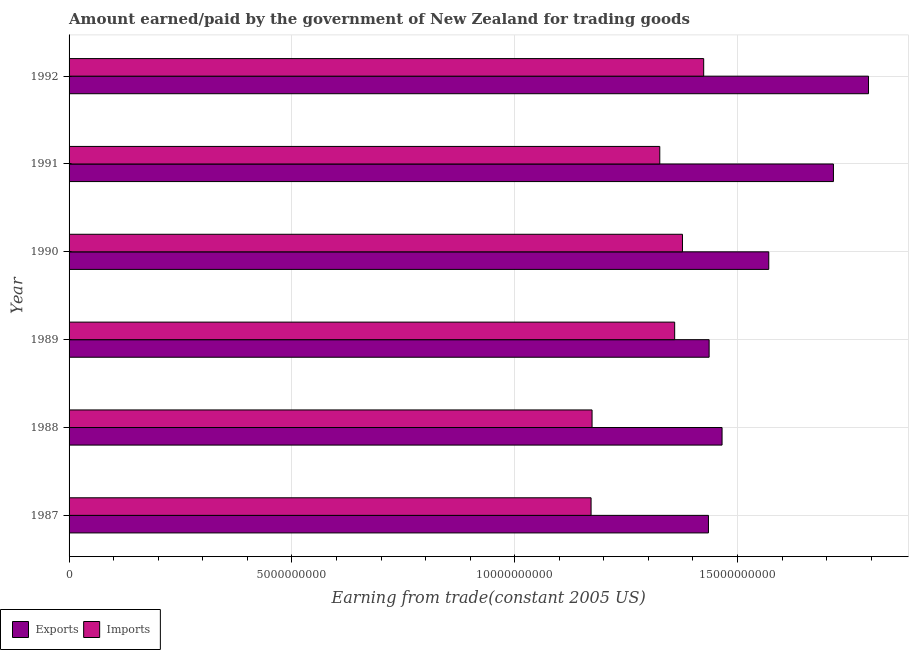How many groups of bars are there?
Provide a short and direct response. 6. Are the number of bars per tick equal to the number of legend labels?
Offer a very short reply. Yes. How many bars are there on the 3rd tick from the top?
Offer a very short reply. 2. How many bars are there on the 6th tick from the bottom?
Keep it short and to the point. 2. What is the amount earned from exports in 1992?
Offer a very short reply. 1.79e+1. Across all years, what is the maximum amount earned from exports?
Offer a very short reply. 1.79e+1. Across all years, what is the minimum amount earned from exports?
Provide a short and direct response. 1.43e+1. What is the total amount earned from exports in the graph?
Ensure brevity in your answer.  9.42e+1. What is the difference between the amount paid for imports in 1988 and that in 1990?
Ensure brevity in your answer.  -2.03e+09. What is the difference between the amount paid for imports in 1990 and the amount earned from exports in 1989?
Your answer should be compact. -5.98e+08. What is the average amount earned from exports per year?
Your answer should be compact. 1.57e+1. In the year 1992, what is the difference between the amount paid for imports and amount earned from exports?
Your answer should be compact. -3.70e+09. What is the ratio of the amount paid for imports in 1987 to that in 1992?
Ensure brevity in your answer.  0.82. Is the amount paid for imports in 1989 less than that in 1990?
Provide a succinct answer. Yes. Is the difference between the amount earned from exports in 1987 and 1992 greater than the difference between the amount paid for imports in 1987 and 1992?
Make the answer very short. No. What is the difference between the highest and the second highest amount earned from exports?
Offer a very short reply. 7.87e+08. What is the difference between the highest and the lowest amount paid for imports?
Offer a very short reply. 2.53e+09. What does the 1st bar from the top in 1989 represents?
Your answer should be very brief. Imports. What does the 1st bar from the bottom in 1987 represents?
Provide a succinct answer. Exports. Are all the bars in the graph horizontal?
Keep it short and to the point. Yes. How many years are there in the graph?
Provide a short and direct response. 6. What is the difference between two consecutive major ticks on the X-axis?
Give a very brief answer. 5.00e+09. Are the values on the major ticks of X-axis written in scientific E-notation?
Ensure brevity in your answer.  No. How are the legend labels stacked?
Keep it short and to the point. Horizontal. What is the title of the graph?
Make the answer very short. Amount earned/paid by the government of New Zealand for trading goods. Does "By country of origin" appear as one of the legend labels in the graph?
Ensure brevity in your answer.  No. What is the label or title of the X-axis?
Your answer should be compact. Earning from trade(constant 2005 US). What is the Earning from trade(constant 2005 US) in Exports in 1987?
Offer a terse response. 1.43e+1. What is the Earning from trade(constant 2005 US) in Imports in 1987?
Offer a terse response. 1.17e+1. What is the Earning from trade(constant 2005 US) of Exports in 1988?
Ensure brevity in your answer.  1.47e+1. What is the Earning from trade(constant 2005 US) in Imports in 1988?
Your answer should be very brief. 1.17e+1. What is the Earning from trade(constant 2005 US) of Exports in 1989?
Provide a short and direct response. 1.44e+1. What is the Earning from trade(constant 2005 US) in Imports in 1989?
Provide a succinct answer. 1.36e+1. What is the Earning from trade(constant 2005 US) in Exports in 1990?
Ensure brevity in your answer.  1.57e+1. What is the Earning from trade(constant 2005 US) in Imports in 1990?
Provide a short and direct response. 1.38e+1. What is the Earning from trade(constant 2005 US) in Exports in 1991?
Your response must be concise. 1.72e+1. What is the Earning from trade(constant 2005 US) in Imports in 1991?
Offer a very short reply. 1.33e+1. What is the Earning from trade(constant 2005 US) in Exports in 1992?
Your answer should be compact. 1.79e+1. What is the Earning from trade(constant 2005 US) of Imports in 1992?
Give a very brief answer. 1.42e+1. Across all years, what is the maximum Earning from trade(constant 2005 US) of Exports?
Your answer should be compact. 1.79e+1. Across all years, what is the maximum Earning from trade(constant 2005 US) of Imports?
Provide a succinct answer. 1.42e+1. Across all years, what is the minimum Earning from trade(constant 2005 US) in Exports?
Offer a terse response. 1.43e+1. Across all years, what is the minimum Earning from trade(constant 2005 US) of Imports?
Provide a short and direct response. 1.17e+1. What is the total Earning from trade(constant 2005 US) in Exports in the graph?
Provide a short and direct response. 9.42e+1. What is the total Earning from trade(constant 2005 US) in Imports in the graph?
Ensure brevity in your answer.  7.83e+1. What is the difference between the Earning from trade(constant 2005 US) of Exports in 1987 and that in 1988?
Offer a very short reply. -3.05e+08. What is the difference between the Earning from trade(constant 2005 US) in Imports in 1987 and that in 1988?
Your answer should be very brief. -2.22e+07. What is the difference between the Earning from trade(constant 2005 US) of Exports in 1987 and that in 1989?
Make the answer very short. -1.52e+07. What is the difference between the Earning from trade(constant 2005 US) in Imports in 1987 and that in 1989?
Your answer should be very brief. -1.88e+09. What is the difference between the Earning from trade(constant 2005 US) of Exports in 1987 and that in 1990?
Your response must be concise. -1.35e+09. What is the difference between the Earning from trade(constant 2005 US) of Imports in 1987 and that in 1990?
Provide a succinct answer. -2.05e+09. What is the difference between the Earning from trade(constant 2005 US) of Exports in 1987 and that in 1991?
Your answer should be very brief. -2.80e+09. What is the difference between the Earning from trade(constant 2005 US) in Imports in 1987 and that in 1991?
Your answer should be compact. -1.54e+09. What is the difference between the Earning from trade(constant 2005 US) in Exports in 1987 and that in 1992?
Your answer should be compact. -3.59e+09. What is the difference between the Earning from trade(constant 2005 US) in Imports in 1987 and that in 1992?
Provide a succinct answer. -2.53e+09. What is the difference between the Earning from trade(constant 2005 US) of Exports in 1988 and that in 1989?
Your answer should be compact. 2.90e+08. What is the difference between the Earning from trade(constant 2005 US) in Imports in 1988 and that in 1989?
Provide a short and direct response. -1.85e+09. What is the difference between the Earning from trade(constant 2005 US) in Exports in 1988 and that in 1990?
Your answer should be compact. -1.05e+09. What is the difference between the Earning from trade(constant 2005 US) of Imports in 1988 and that in 1990?
Give a very brief answer. -2.03e+09. What is the difference between the Earning from trade(constant 2005 US) of Exports in 1988 and that in 1991?
Make the answer very short. -2.50e+09. What is the difference between the Earning from trade(constant 2005 US) of Imports in 1988 and that in 1991?
Keep it short and to the point. -1.52e+09. What is the difference between the Earning from trade(constant 2005 US) in Exports in 1988 and that in 1992?
Provide a succinct answer. -3.29e+09. What is the difference between the Earning from trade(constant 2005 US) of Imports in 1988 and that in 1992?
Offer a terse response. -2.51e+09. What is the difference between the Earning from trade(constant 2005 US) of Exports in 1989 and that in 1990?
Offer a very short reply. -1.34e+09. What is the difference between the Earning from trade(constant 2005 US) in Imports in 1989 and that in 1990?
Keep it short and to the point. -1.75e+08. What is the difference between the Earning from trade(constant 2005 US) of Exports in 1989 and that in 1991?
Keep it short and to the point. -2.79e+09. What is the difference between the Earning from trade(constant 2005 US) in Imports in 1989 and that in 1991?
Keep it short and to the point. 3.34e+08. What is the difference between the Earning from trade(constant 2005 US) in Exports in 1989 and that in 1992?
Provide a short and direct response. -3.58e+09. What is the difference between the Earning from trade(constant 2005 US) of Imports in 1989 and that in 1992?
Your answer should be compact. -6.51e+08. What is the difference between the Earning from trade(constant 2005 US) of Exports in 1990 and that in 1991?
Provide a succinct answer. -1.45e+09. What is the difference between the Earning from trade(constant 2005 US) of Imports in 1990 and that in 1991?
Offer a terse response. 5.09e+08. What is the difference between the Earning from trade(constant 2005 US) of Exports in 1990 and that in 1992?
Give a very brief answer. -2.24e+09. What is the difference between the Earning from trade(constant 2005 US) of Imports in 1990 and that in 1992?
Provide a succinct answer. -4.76e+08. What is the difference between the Earning from trade(constant 2005 US) of Exports in 1991 and that in 1992?
Ensure brevity in your answer.  -7.87e+08. What is the difference between the Earning from trade(constant 2005 US) in Imports in 1991 and that in 1992?
Keep it short and to the point. -9.86e+08. What is the difference between the Earning from trade(constant 2005 US) in Exports in 1987 and the Earning from trade(constant 2005 US) in Imports in 1988?
Ensure brevity in your answer.  2.61e+09. What is the difference between the Earning from trade(constant 2005 US) of Exports in 1987 and the Earning from trade(constant 2005 US) of Imports in 1989?
Provide a short and direct response. 7.58e+08. What is the difference between the Earning from trade(constant 2005 US) of Exports in 1987 and the Earning from trade(constant 2005 US) of Imports in 1990?
Your response must be concise. 5.83e+08. What is the difference between the Earning from trade(constant 2005 US) in Exports in 1987 and the Earning from trade(constant 2005 US) in Imports in 1991?
Offer a terse response. 1.09e+09. What is the difference between the Earning from trade(constant 2005 US) of Exports in 1987 and the Earning from trade(constant 2005 US) of Imports in 1992?
Your answer should be very brief. 1.07e+08. What is the difference between the Earning from trade(constant 2005 US) of Exports in 1988 and the Earning from trade(constant 2005 US) of Imports in 1989?
Ensure brevity in your answer.  1.06e+09. What is the difference between the Earning from trade(constant 2005 US) of Exports in 1988 and the Earning from trade(constant 2005 US) of Imports in 1990?
Offer a terse response. 8.89e+08. What is the difference between the Earning from trade(constant 2005 US) of Exports in 1988 and the Earning from trade(constant 2005 US) of Imports in 1991?
Your response must be concise. 1.40e+09. What is the difference between the Earning from trade(constant 2005 US) in Exports in 1988 and the Earning from trade(constant 2005 US) in Imports in 1992?
Ensure brevity in your answer.  4.12e+08. What is the difference between the Earning from trade(constant 2005 US) in Exports in 1989 and the Earning from trade(constant 2005 US) in Imports in 1990?
Offer a terse response. 5.98e+08. What is the difference between the Earning from trade(constant 2005 US) in Exports in 1989 and the Earning from trade(constant 2005 US) in Imports in 1991?
Offer a very short reply. 1.11e+09. What is the difference between the Earning from trade(constant 2005 US) in Exports in 1989 and the Earning from trade(constant 2005 US) in Imports in 1992?
Provide a succinct answer. 1.22e+08. What is the difference between the Earning from trade(constant 2005 US) in Exports in 1990 and the Earning from trade(constant 2005 US) in Imports in 1991?
Offer a terse response. 2.45e+09. What is the difference between the Earning from trade(constant 2005 US) of Exports in 1990 and the Earning from trade(constant 2005 US) of Imports in 1992?
Ensure brevity in your answer.  1.46e+09. What is the difference between the Earning from trade(constant 2005 US) in Exports in 1991 and the Earning from trade(constant 2005 US) in Imports in 1992?
Your answer should be very brief. 2.91e+09. What is the average Earning from trade(constant 2005 US) of Exports per year?
Your response must be concise. 1.57e+1. What is the average Earning from trade(constant 2005 US) in Imports per year?
Provide a short and direct response. 1.31e+1. In the year 1987, what is the difference between the Earning from trade(constant 2005 US) in Exports and Earning from trade(constant 2005 US) in Imports?
Your answer should be very brief. 2.63e+09. In the year 1988, what is the difference between the Earning from trade(constant 2005 US) in Exports and Earning from trade(constant 2005 US) in Imports?
Give a very brief answer. 2.92e+09. In the year 1989, what is the difference between the Earning from trade(constant 2005 US) of Exports and Earning from trade(constant 2005 US) of Imports?
Make the answer very short. 7.73e+08. In the year 1990, what is the difference between the Earning from trade(constant 2005 US) of Exports and Earning from trade(constant 2005 US) of Imports?
Keep it short and to the point. 1.94e+09. In the year 1991, what is the difference between the Earning from trade(constant 2005 US) of Exports and Earning from trade(constant 2005 US) of Imports?
Ensure brevity in your answer.  3.90e+09. In the year 1992, what is the difference between the Earning from trade(constant 2005 US) of Exports and Earning from trade(constant 2005 US) of Imports?
Make the answer very short. 3.70e+09. What is the ratio of the Earning from trade(constant 2005 US) of Exports in 1987 to that in 1988?
Provide a short and direct response. 0.98. What is the ratio of the Earning from trade(constant 2005 US) of Exports in 1987 to that in 1989?
Your answer should be very brief. 1. What is the ratio of the Earning from trade(constant 2005 US) of Imports in 1987 to that in 1989?
Keep it short and to the point. 0.86. What is the ratio of the Earning from trade(constant 2005 US) of Exports in 1987 to that in 1990?
Make the answer very short. 0.91. What is the ratio of the Earning from trade(constant 2005 US) in Imports in 1987 to that in 1990?
Offer a very short reply. 0.85. What is the ratio of the Earning from trade(constant 2005 US) of Exports in 1987 to that in 1991?
Your response must be concise. 0.84. What is the ratio of the Earning from trade(constant 2005 US) of Imports in 1987 to that in 1991?
Keep it short and to the point. 0.88. What is the ratio of the Earning from trade(constant 2005 US) in Exports in 1987 to that in 1992?
Make the answer very short. 0.8. What is the ratio of the Earning from trade(constant 2005 US) in Imports in 1987 to that in 1992?
Your answer should be compact. 0.82. What is the ratio of the Earning from trade(constant 2005 US) of Exports in 1988 to that in 1989?
Offer a terse response. 1.02. What is the ratio of the Earning from trade(constant 2005 US) in Imports in 1988 to that in 1989?
Provide a succinct answer. 0.86. What is the ratio of the Earning from trade(constant 2005 US) in Exports in 1988 to that in 1990?
Offer a very short reply. 0.93. What is the ratio of the Earning from trade(constant 2005 US) in Imports in 1988 to that in 1990?
Your answer should be compact. 0.85. What is the ratio of the Earning from trade(constant 2005 US) in Exports in 1988 to that in 1991?
Ensure brevity in your answer.  0.85. What is the ratio of the Earning from trade(constant 2005 US) of Imports in 1988 to that in 1991?
Ensure brevity in your answer.  0.89. What is the ratio of the Earning from trade(constant 2005 US) of Exports in 1988 to that in 1992?
Keep it short and to the point. 0.82. What is the ratio of the Earning from trade(constant 2005 US) in Imports in 1988 to that in 1992?
Provide a short and direct response. 0.82. What is the ratio of the Earning from trade(constant 2005 US) in Exports in 1989 to that in 1990?
Give a very brief answer. 0.91. What is the ratio of the Earning from trade(constant 2005 US) in Imports in 1989 to that in 1990?
Provide a succinct answer. 0.99. What is the ratio of the Earning from trade(constant 2005 US) in Exports in 1989 to that in 1991?
Ensure brevity in your answer.  0.84. What is the ratio of the Earning from trade(constant 2005 US) of Imports in 1989 to that in 1991?
Offer a terse response. 1.03. What is the ratio of the Earning from trade(constant 2005 US) in Exports in 1989 to that in 1992?
Provide a short and direct response. 0.8. What is the ratio of the Earning from trade(constant 2005 US) of Imports in 1989 to that in 1992?
Provide a short and direct response. 0.95. What is the ratio of the Earning from trade(constant 2005 US) of Exports in 1990 to that in 1991?
Make the answer very short. 0.92. What is the ratio of the Earning from trade(constant 2005 US) of Imports in 1990 to that in 1991?
Give a very brief answer. 1.04. What is the ratio of the Earning from trade(constant 2005 US) in Exports in 1990 to that in 1992?
Give a very brief answer. 0.88. What is the ratio of the Earning from trade(constant 2005 US) of Imports in 1990 to that in 1992?
Make the answer very short. 0.97. What is the ratio of the Earning from trade(constant 2005 US) in Exports in 1991 to that in 1992?
Your answer should be very brief. 0.96. What is the ratio of the Earning from trade(constant 2005 US) of Imports in 1991 to that in 1992?
Offer a terse response. 0.93. What is the difference between the highest and the second highest Earning from trade(constant 2005 US) of Exports?
Your response must be concise. 7.87e+08. What is the difference between the highest and the second highest Earning from trade(constant 2005 US) of Imports?
Your answer should be very brief. 4.76e+08. What is the difference between the highest and the lowest Earning from trade(constant 2005 US) of Exports?
Your answer should be very brief. 3.59e+09. What is the difference between the highest and the lowest Earning from trade(constant 2005 US) of Imports?
Keep it short and to the point. 2.53e+09. 